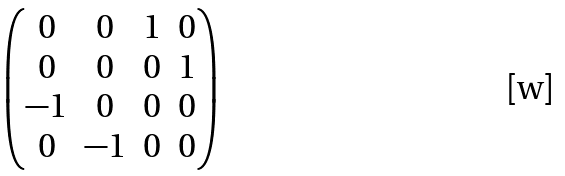Convert formula to latex. <formula><loc_0><loc_0><loc_500><loc_500>\begin{pmatrix} 0 & 0 & 1 & 0 \\ 0 & 0 & 0 & 1 \\ - 1 & 0 & 0 & 0 \\ 0 & - 1 & 0 & 0 \\ \end{pmatrix}</formula> 